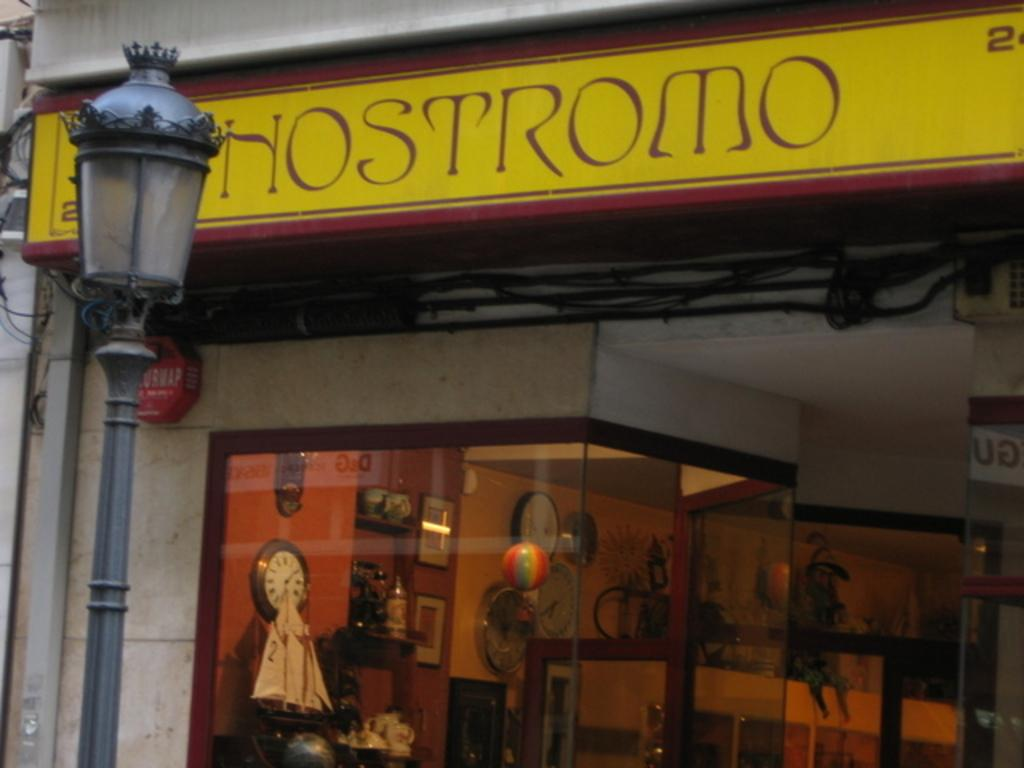<image>
Describe the image concisely. Hostromo building with multiple clocks on the inside 